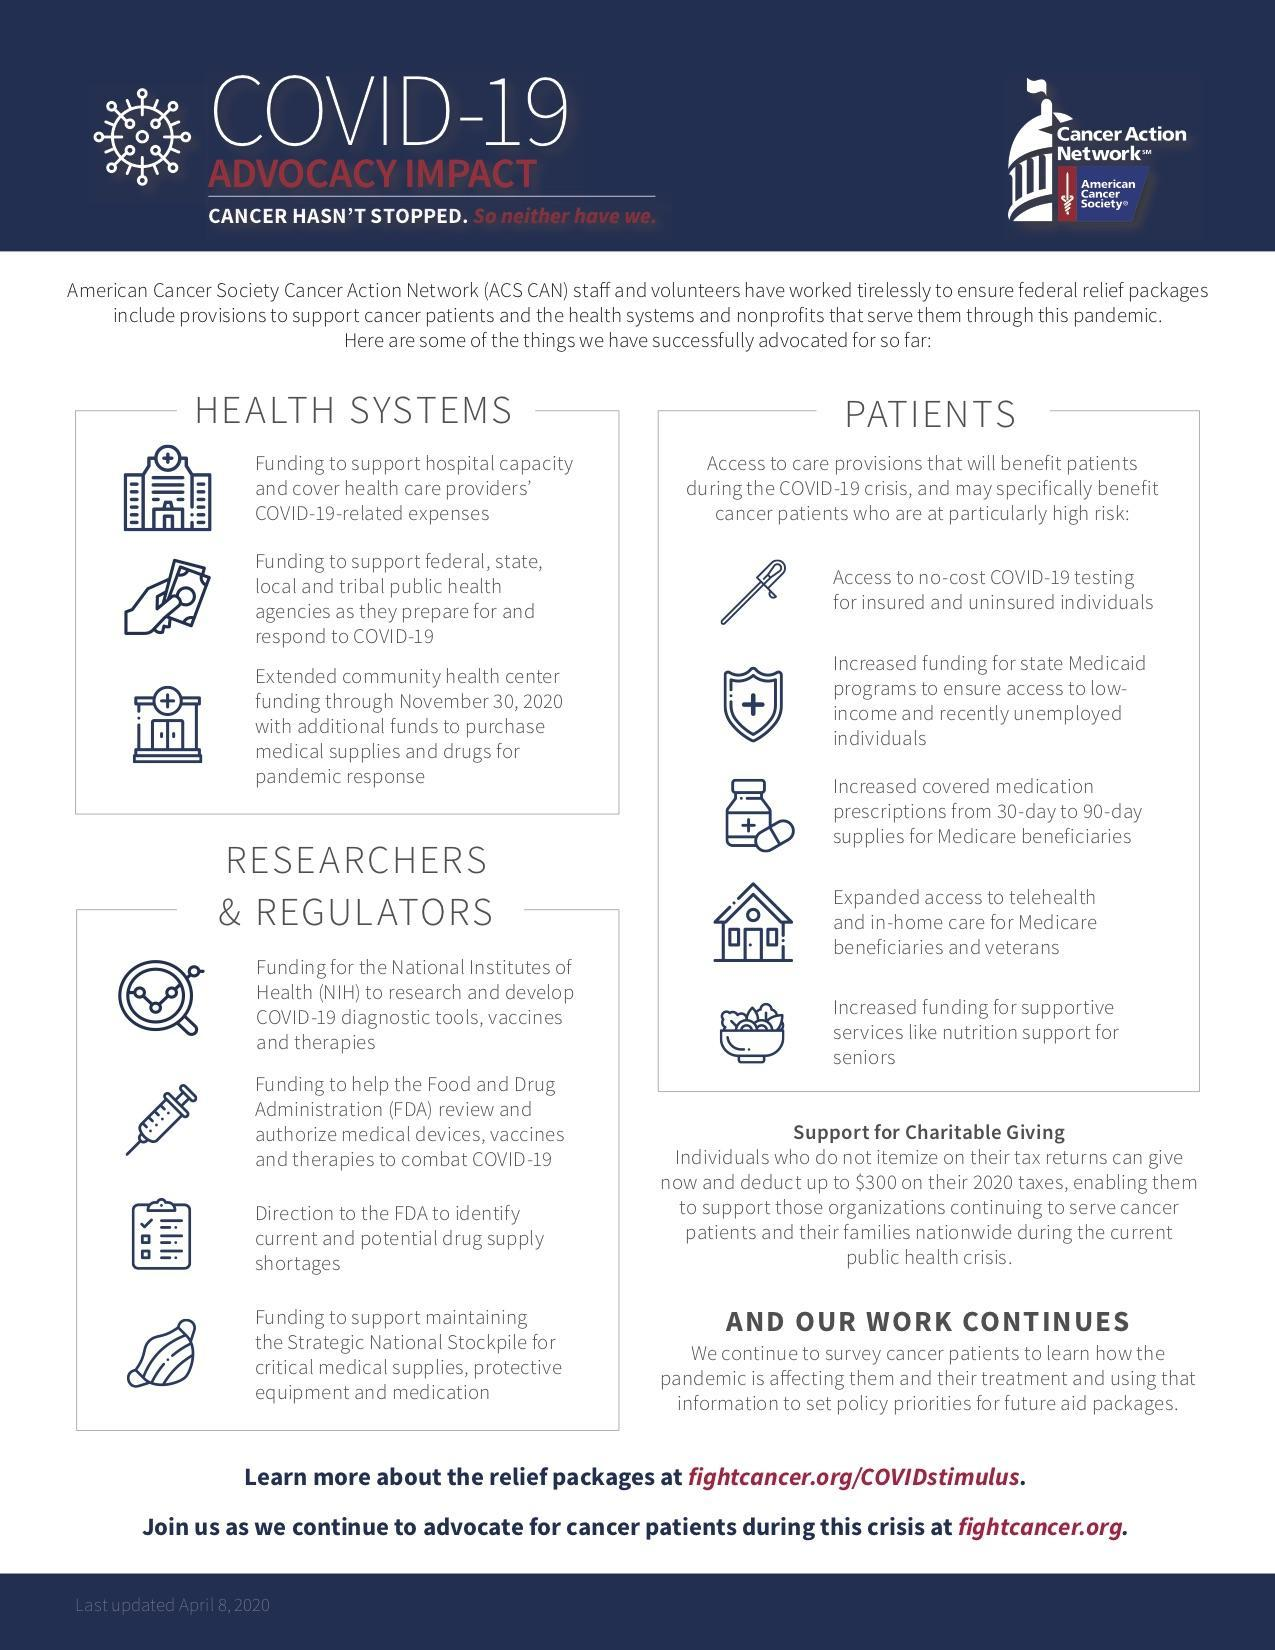What are the benefits available for senior patients?
Answer the question with a short phrase. Increased funding for supportive services like nutrition support What is the funding for National Institutes of health used for? research and develop covid-19 diagnostic tools, vaccines and therapies Who is provided with access to no-cost covid-19 testing? Insured and uninsured individuals How many benefits are available for the health systems? 3 How many points are mentioned under the heading 'patients'? 5 Which are the public health agencies that receive funding to prepare for Covid-19? Federal, state, local and tribal For whom is Access to telehealth and in-home care made available? Medicare beneficiaries and veterans What are the three essentials stocked in the Strategic National Stockpile? Critical medical supplies, protective equipment and medication Which program benefits low-income and recently unemployed individuals? Medicaid program Why were additional funds given to community health centres? To purchase medical supplies and drugs for pandemic response 